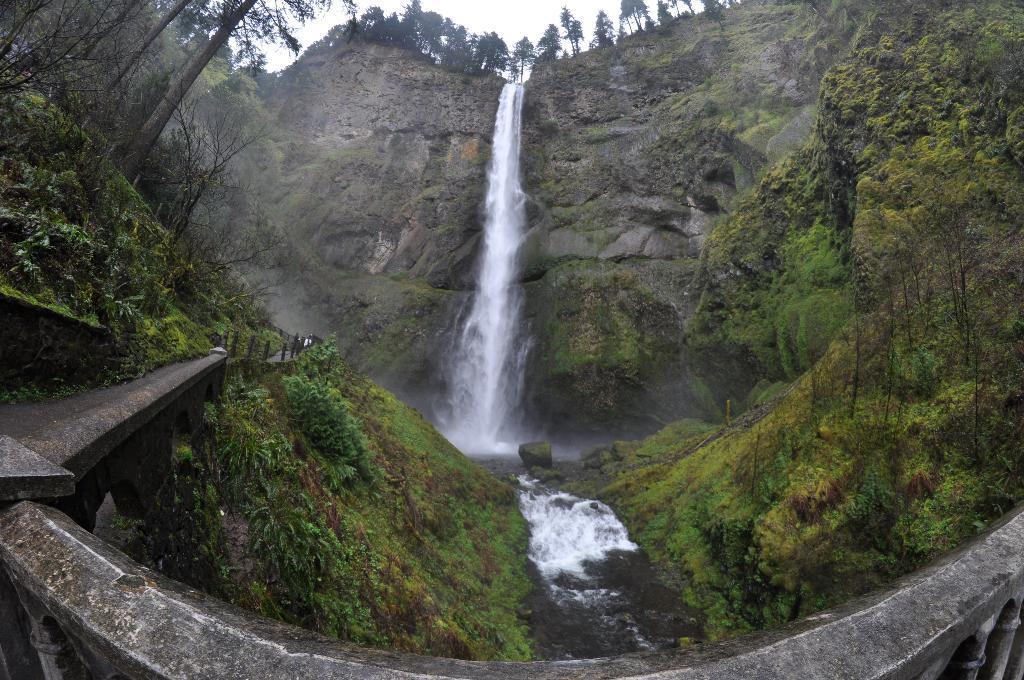In one or two sentences, can you explain what this image depicts? In this image in the front there is a railing. In the center there are plants, there is water and there's grass on the ground. In the background there is a waterfall and there are rocks and trees. 